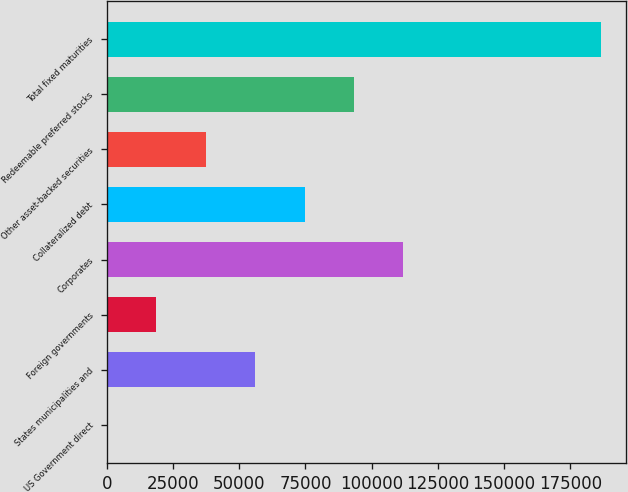Convert chart. <chart><loc_0><loc_0><loc_500><loc_500><bar_chart><fcel>US Government direct<fcel>States municipalities and<fcel>Foreign governments<fcel>Corporates<fcel>Collateralized debt<fcel>Other asset-backed securities<fcel>Redeemable preferred stocks<fcel>Total fixed maturities<nl><fcel>1<fcel>56001.4<fcel>18667.8<fcel>112002<fcel>74668.2<fcel>37334.6<fcel>93335<fcel>186669<nl></chart> 